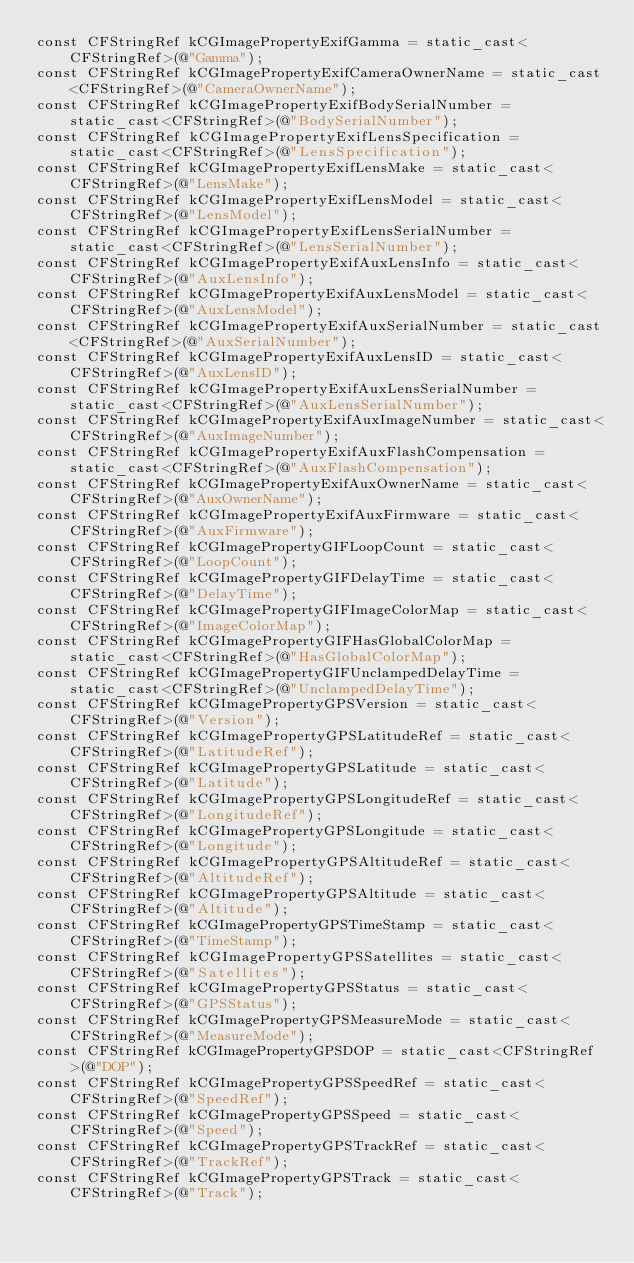Convert code to text. <code><loc_0><loc_0><loc_500><loc_500><_ObjectiveC_>const CFStringRef kCGImagePropertyExifGamma = static_cast<CFStringRef>(@"Gamma");
const CFStringRef kCGImagePropertyExifCameraOwnerName = static_cast<CFStringRef>(@"CameraOwnerName");
const CFStringRef kCGImagePropertyExifBodySerialNumber = static_cast<CFStringRef>(@"BodySerialNumber");
const CFStringRef kCGImagePropertyExifLensSpecification = static_cast<CFStringRef>(@"LensSpecification");
const CFStringRef kCGImagePropertyExifLensMake = static_cast<CFStringRef>(@"LensMake");
const CFStringRef kCGImagePropertyExifLensModel = static_cast<CFStringRef>(@"LensModel");
const CFStringRef kCGImagePropertyExifLensSerialNumber = static_cast<CFStringRef>(@"LensSerialNumber");
const CFStringRef kCGImagePropertyExifAuxLensInfo = static_cast<CFStringRef>(@"AuxLensInfo");
const CFStringRef kCGImagePropertyExifAuxLensModel = static_cast<CFStringRef>(@"AuxLensModel");
const CFStringRef kCGImagePropertyExifAuxSerialNumber = static_cast<CFStringRef>(@"AuxSerialNumber");
const CFStringRef kCGImagePropertyExifAuxLensID = static_cast<CFStringRef>(@"AuxLensID");
const CFStringRef kCGImagePropertyExifAuxLensSerialNumber = static_cast<CFStringRef>(@"AuxLensSerialNumber");
const CFStringRef kCGImagePropertyExifAuxImageNumber = static_cast<CFStringRef>(@"AuxImageNumber");
const CFStringRef kCGImagePropertyExifAuxFlashCompensation = static_cast<CFStringRef>(@"AuxFlashCompensation");
const CFStringRef kCGImagePropertyExifAuxOwnerName = static_cast<CFStringRef>(@"AuxOwnerName");
const CFStringRef kCGImagePropertyExifAuxFirmware = static_cast<CFStringRef>(@"AuxFirmware");
const CFStringRef kCGImagePropertyGIFLoopCount = static_cast<CFStringRef>(@"LoopCount");
const CFStringRef kCGImagePropertyGIFDelayTime = static_cast<CFStringRef>(@"DelayTime");
const CFStringRef kCGImagePropertyGIFImageColorMap = static_cast<CFStringRef>(@"ImageColorMap");
const CFStringRef kCGImagePropertyGIFHasGlobalColorMap = static_cast<CFStringRef>(@"HasGlobalColorMap");
const CFStringRef kCGImagePropertyGIFUnclampedDelayTime = static_cast<CFStringRef>(@"UnclampedDelayTime");
const CFStringRef kCGImagePropertyGPSVersion = static_cast<CFStringRef>(@"Version");
const CFStringRef kCGImagePropertyGPSLatitudeRef = static_cast<CFStringRef>(@"LatitudeRef");
const CFStringRef kCGImagePropertyGPSLatitude = static_cast<CFStringRef>(@"Latitude");
const CFStringRef kCGImagePropertyGPSLongitudeRef = static_cast<CFStringRef>(@"LongitudeRef");
const CFStringRef kCGImagePropertyGPSLongitude = static_cast<CFStringRef>(@"Longitude");
const CFStringRef kCGImagePropertyGPSAltitudeRef = static_cast<CFStringRef>(@"AltitudeRef");
const CFStringRef kCGImagePropertyGPSAltitude = static_cast<CFStringRef>(@"Altitude");
const CFStringRef kCGImagePropertyGPSTimeStamp = static_cast<CFStringRef>(@"TimeStamp");
const CFStringRef kCGImagePropertyGPSSatellites = static_cast<CFStringRef>(@"Satellites");
const CFStringRef kCGImagePropertyGPSStatus = static_cast<CFStringRef>(@"GPSStatus");
const CFStringRef kCGImagePropertyGPSMeasureMode = static_cast<CFStringRef>(@"MeasureMode");
const CFStringRef kCGImagePropertyGPSDOP = static_cast<CFStringRef>(@"DOP");
const CFStringRef kCGImagePropertyGPSSpeedRef = static_cast<CFStringRef>(@"SpeedRef");
const CFStringRef kCGImagePropertyGPSSpeed = static_cast<CFStringRef>(@"Speed");
const CFStringRef kCGImagePropertyGPSTrackRef = static_cast<CFStringRef>(@"TrackRef");
const CFStringRef kCGImagePropertyGPSTrack = static_cast<CFStringRef>(@"Track");</code> 